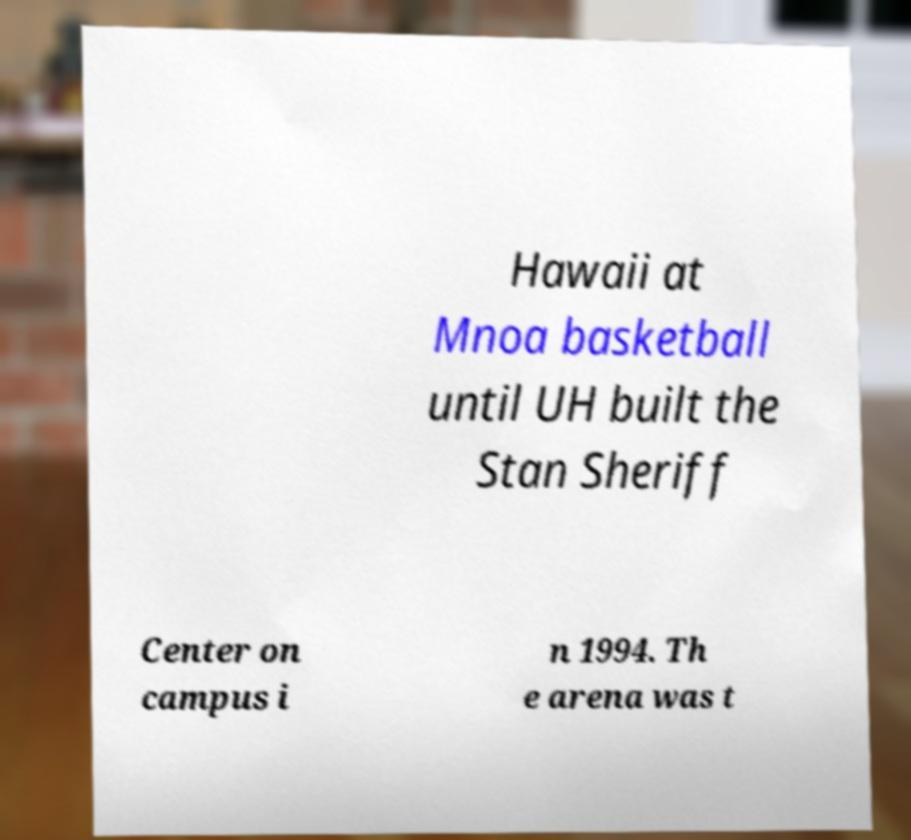Please read and relay the text visible in this image. What does it say? Hawaii at Mnoa basketball until UH built the Stan Sheriff Center on campus i n 1994. Th e arena was t 